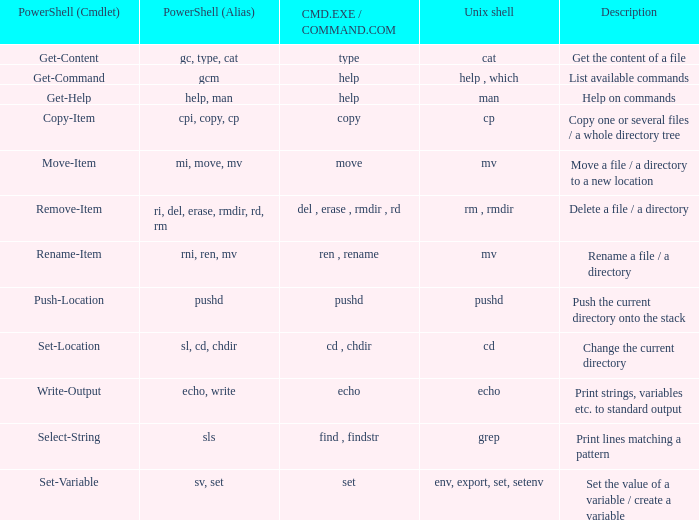When the cmd.exe / command.com is type, what are all associated values for powershell (cmdlet)? Get-Content. 